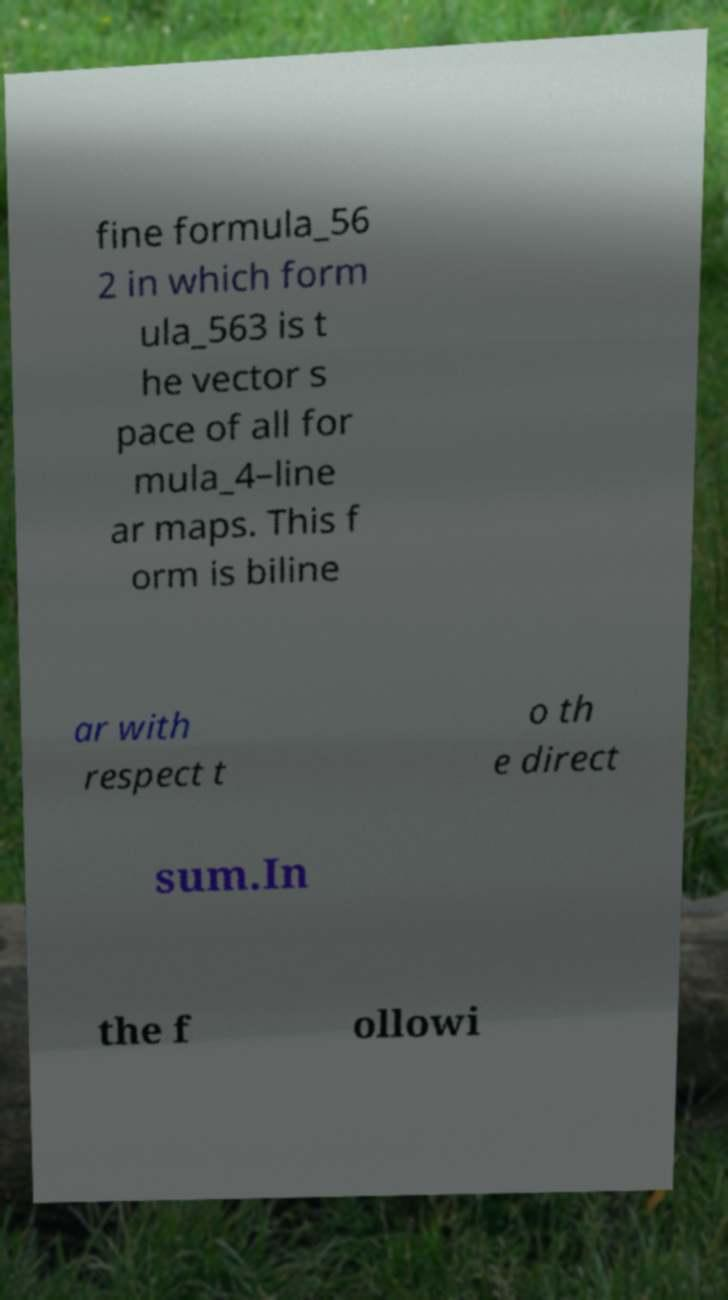Can you read and provide the text displayed in the image?This photo seems to have some interesting text. Can you extract and type it out for me? fine formula_56 2 in which form ula_563 is t he vector s pace of all for mula_4–line ar maps. This f orm is biline ar with respect t o th e direct sum.In the f ollowi 